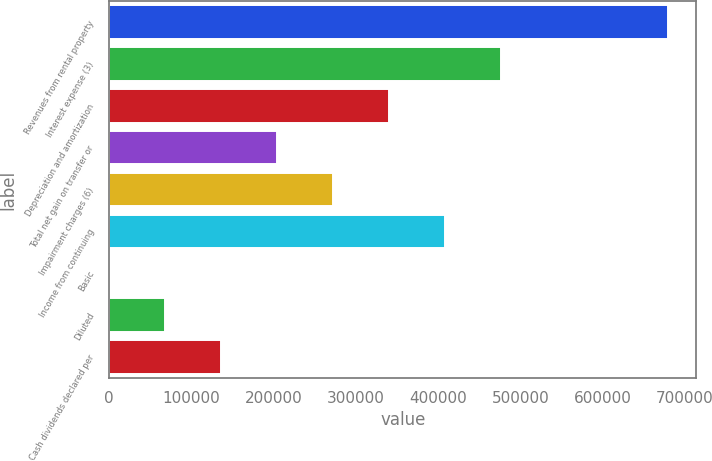<chart> <loc_0><loc_0><loc_500><loc_500><bar_chart><fcel>Revenues from rental property<fcel>Interest expense (3)<fcel>Depreciation and amortization<fcel>Total net gain on transfer or<fcel>Impairment charges (6)<fcel>Income from continuing<fcel>Basic<fcel>Diluted<fcel>Cash dividends declared per<nl><fcel>679966<fcel>475976<fcel>339983<fcel>203990<fcel>271987<fcel>407980<fcel>0.57<fcel>67997.1<fcel>135994<nl></chart> 